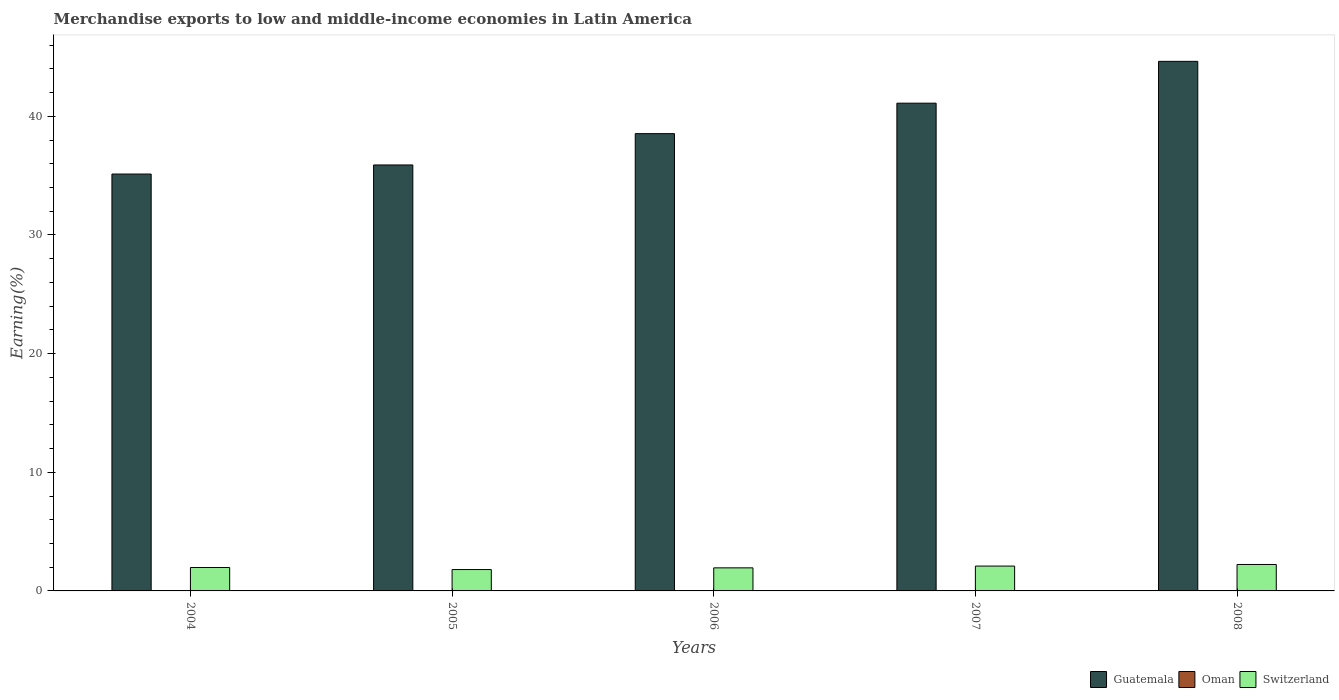How many bars are there on the 3rd tick from the right?
Give a very brief answer. 3. What is the label of the 4th group of bars from the left?
Your answer should be very brief. 2007. In how many cases, is the number of bars for a given year not equal to the number of legend labels?
Offer a terse response. 0. What is the percentage of amount earned from merchandise exports in Oman in 2008?
Provide a succinct answer. 0.01. Across all years, what is the maximum percentage of amount earned from merchandise exports in Switzerland?
Offer a terse response. 2.23. Across all years, what is the minimum percentage of amount earned from merchandise exports in Oman?
Ensure brevity in your answer.  0.01. In which year was the percentage of amount earned from merchandise exports in Switzerland maximum?
Your answer should be compact. 2008. What is the total percentage of amount earned from merchandise exports in Guatemala in the graph?
Give a very brief answer. 195.32. What is the difference between the percentage of amount earned from merchandise exports in Oman in 2005 and that in 2006?
Provide a succinct answer. -0.01. What is the difference between the percentage of amount earned from merchandise exports in Switzerland in 2007 and the percentage of amount earned from merchandise exports in Oman in 2006?
Provide a succinct answer. 2.07. What is the average percentage of amount earned from merchandise exports in Guatemala per year?
Keep it short and to the point. 39.06. In the year 2006, what is the difference between the percentage of amount earned from merchandise exports in Guatemala and percentage of amount earned from merchandise exports in Oman?
Make the answer very short. 38.52. In how many years, is the percentage of amount earned from merchandise exports in Switzerland greater than 24 %?
Your response must be concise. 0. What is the ratio of the percentage of amount earned from merchandise exports in Oman in 2004 to that in 2008?
Your answer should be compact. 0.6. What is the difference between the highest and the second highest percentage of amount earned from merchandise exports in Switzerland?
Provide a succinct answer. 0.13. What is the difference between the highest and the lowest percentage of amount earned from merchandise exports in Switzerland?
Provide a short and direct response. 0.43. In how many years, is the percentage of amount earned from merchandise exports in Switzerland greater than the average percentage of amount earned from merchandise exports in Switzerland taken over all years?
Your response must be concise. 2. What does the 2nd bar from the left in 2008 represents?
Make the answer very short. Oman. What does the 2nd bar from the right in 2007 represents?
Ensure brevity in your answer.  Oman. Are all the bars in the graph horizontal?
Keep it short and to the point. No. Are the values on the major ticks of Y-axis written in scientific E-notation?
Provide a short and direct response. No. Does the graph contain grids?
Your answer should be very brief. No. Where does the legend appear in the graph?
Your response must be concise. Bottom right. How are the legend labels stacked?
Provide a short and direct response. Horizontal. What is the title of the graph?
Your answer should be very brief. Merchandise exports to low and middle-income economies in Latin America. Does "Greenland" appear as one of the legend labels in the graph?
Provide a short and direct response. No. What is the label or title of the Y-axis?
Offer a terse response. Earning(%). What is the Earning(%) in Guatemala in 2004?
Keep it short and to the point. 35.14. What is the Earning(%) in Oman in 2004?
Your response must be concise. 0.01. What is the Earning(%) in Switzerland in 2004?
Ensure brevity in your answer.  1.97. What is the Earning(%) of Guatemala in 2005?
Provide a short and direct response. 35.9. What is the Earning(%) of Oman in 2005?
Offer a very short reply. 0.01. What is the Earning(%) in Switzerland in 2005?
Your response must be concise. 1.8. What is the Earning(%) of Guatemala in 2006?
Provide a succinct answer. 38.54. What is the Earning(%) of Oman in 2006?
Your answer should be compact. 0.02. What is the Earning(%) in Switzerland in 2006?
Provide a succinct answer. 1.94. What is the Earning(%) in Guatemala in 2007?
Keep it short and to the point. 41.11. What is the Earning(%) of Oman in 2007?
Offer a very short reply. 0.02. What is the Earning(%) of Switzerland in 2007?
Give a very brief answer. 2.09. What is the Earning(%) of Guatemala in 2008?
Keep it short and to the point. 44.63. What is the Earning(%) in Oman in 2008?
Make the answer very short. 0.01. What is the Earning(%) in Switzerland in 2008?
Ensure brevity in your answer.  2.23. Across all years, what is the maximum Earning(%) in Guatemala?
Your response must be concise. 44.63. Across all years, what is the maximum Earning(%) in Oman?
Your answer should be very brief. 0.02. Across all years, what is the maximum Earning(%) in Switzerland?
Make the answer very short. 2.23. Across all years, what is the minimum Earning(%) in Guatemala?
Offer a very short reply. 35.14. Across all years, what is the minimum Earning(%) of Oman?
Your answer should be very brief. 0.01. Across all years, what is the minimum Earning(%) of Switzerland?
Offer a very short reply. 1.8. What is the total Earning(%) of Guatemala in the graph?
Your response must be concise. 195.32. What is the total Earning(%) of Oman in the graph?
Keep it short and to the point. 0.06. What is the total Earning(%) in Switzerland in the graph?
Keep it short and to the point. 10.04. What is the difference between the Earning(%) in Guatemala in 2004 and that in 2005?
Your answer should be compact. -0.77. What is the difference between the Earning(%) in Oman in 2004 and that in 2005?
Keep it short and to the point. -0. What is the difference between the Earning(%) of Switzerland in 2004 and that in 2005?
Your answer should be very brief. 0.17. What is the difference between the Earning(%) of Guatemala in 2004 and that in 2006?
Provide a short and direct response. -3.41. What is the difference between the Earning(%) of Oman in 2004 and that in 2006?
Keep it short and to the point. -0.02. What is the difference between the Earning(%) in Switzerland in 2004 and that in 2006?
Give a very brief answer. 0.03. What is the difference between the Earning(%) of Guatemala in 2004 and that in 2007?
Your response must be concise. -5.97. What is the difference between the Earning(%) in Oman in 2004 and that in 2007?
Ensure brevity in your answer.  -0.01. What is the difference between the Earning(%) in Switzerland in 2004 and that in 2007?
Your response must be concise. -0.12. What is the difference between the Earning(%) in Guatemala in 2004 and that in 2008?
Provide a short and direct response. -9.5. What is the difference between the Earning(%) in Oman in 2004 and that in 2008?
Your response must be concise. -0. What is the difference between the Earning(%) in Switzerland in 2004 and that in 2008?
Your answer should be very brief. -0.26. What is the difference between the Earning(%) of Guatemala in 2005 and that in 2006?
Provide a succinct answer. -2.64. What is the difference between the Earning(%) of Oman in 2005 and that in 2006?
Provide a short and direct response. -0.01. What is the difference between the Earning(%) of Switzerland in 2005 and that in 2006?
Your answer should be very brief. -0.14. What is the difference between the Earning(%) in Guatemala in 2005 and that in 2007?
Keep it short and to the point. -5.21. What is the difference between the Earning(%) in Oman in 2005 and that in 2007?
Ensure brevity in your answer.  -0.01. What is the difference between the Earning(%) in Switzerland in 2005 and that in 2007?
Give a very brief answer. -0.29. What is the difference between the Earning(%) of Guatemala in 2005 and that in 2008?
Offer a very short reply. -8.73. What is the difference between the Earning(%) of Oman in 2005 and that in 2008?
Give a very brief answer. -0. What is the difference between the Earning(%) of Switzerland in 2005 and that in 2008?
Your answer should be very brief. -0.43. What is the difference between the Earning(%) of Guatemala in 2006 and that in 2007?
Your response must be concise. -2.57. What is the difference between the Earning(%) in Oman in 2006 and that in 2007?
Provide a succinct answer. 0. What is the difference between the Earning(%) in Switzerland in 2006 and that in 2007?
Your answer should be very brief. -0.15. What is the difference between the Earning(%) of Guatemala in 2006 and that in 2008?
Your response must be concise. -6.09. What is the difference between the Earning(%) of Oman in 2006 and that in 2008?
Ensure brevity in your answer.  0.01. What is the difference between the Earning(%) in Switzerland in 2006 and that in 2008?
Your response must be concise. -0.28. What is the difference between the Earning(%) of Guatemala in 2007 and that in 2008?
Offer a very short reply. -3.53. What is the difference between the Earning(%) in Oman in 2007 and that in 2008?
Provide a short and direct response. 0.01. What is the difference between the Earning(%) in Switzerland in 2007 and that in 2008?
Offer a terse response. -0.13. What is the difference between the Earning(%) in Guatemala in 2004 and the Earning(%) in Oman in 2005?
Keep it short and to the point. 35.13. What is the difference between the Earning(%) in Guatemala in 2004 and the Earning(%) in Switzerland in 2005?
Ensure brevity in your answer.  33.33. What is the difference between the Earning(%) of Oman in 2004 and the Earning(%) of Switzerland in 2005?
Keep it short and to the point. -1.8. What is the difference between the Earning(%) in Guatemala in 2004 and the Earning(%) in Oman in 2006?
Your response must be concise. 35.11. What is the difference between the Earning(%) in Guatemala in 2004 and the Earning(%) in Switzerland in 2006?
Give a very brief answer. 33.19. What is the difference between the Earning(%) of Oman in 2004 and the Earning(%) of Switzerland in 2006?
Make the answer very short. -1.94. What is the difference between the Earning(%) in Guatemala in 2004 and the Earning(%) in Oman in 2007?
Provide a succinct answer. 35.12. What is the difference between the Earning(%) of Guatemala in 2004 and the Earning(%) of Switzerland in 2007?
Your response must be concise. 33.04. What is the difference between the Earning(%) in Oman in 2004 and the Earning(%) in Switzerland in 2007?
Your response must be concise. -2.09. What is the difference between the Earning(%) in Guatemala in 2004 and the Earning(%) in Oman in 2008?
Your answer should be very brief. 35.13. What is the difference between the Earning(%) in Guatemala in 2004 and the Earning(%) in Switzerland in 2008?
Offer a very short reply. 32.91. What is the difference between the Earning(%) in Oman in 2004 and the Earning(%) in Switzerland in 2008?
Ensure brevity in your answer.  -2.22. What is the difference between the Earning(%) of Guatemala in 2005 and the Earning(%) of Oman in 2006?
Make the answer very short. 35.88. What is the difference between the Earning(%) of Guatemala in 2005 and the Earning(%) of Switzerland in 2006?
Your response must be concise. 33.96. What is the difference between the Earning(%) of Oman in 2005 and the Earning(%) of Switzerland in 2006?
Provide a succinct answer. -1.94. What is the difference between the Earning(%) in Guatemala in 2005 and the Earning(%) in Oman in 2007?
Provide a succinct answer. 35.88. What is the difference between the Earning(%) of Guatemala in 2005 and the Earning(%) of Switzerland in 2007?
Ensure brevity in your answer.  33.81. What is the difference between the Earning(%) in Oman in 2005 and the Earning(%) in Switzerland in 2007?
Your answer should be very brief. -2.09. What is the difference between the Earning(%) in Guatemala in 2005 and the Earning(%) in Oman in 2008?
Provide a short and direct response. 35.89. What is the difference between the Earning(%) in Guatemala in 2005 and the Earning(%) in Switzerland in 2008?
Offer a very short reply. 33.67. What is the difference between the Earning(%) of Oman in 2005 and the Earning(%) of Switzerland in 2008?
Keep it short and to the point. -2.22. What is the difference between the Earning(%) in Guatemala in 2006 and the Earning(%) in Oman in 2007?
Offer a terse response. 38.52. What is the difference between the Earning(%) in Guatemala in 2006 and the Earning(%) in Switzerland in 2007?
Make the answer very short. 36.45. What is the difference between the Earning(%) of Oman in 2006 and the Earning(%) of Switzerland in 2007?
Your response must be concise. -2.07. What is the difference between the Earning(%) of Guatemala in 2006 and the Earning(%) of Oman in 2008?
Make the answer very short. 38.53. What is the difference between the Earning(%) in Guatemala in 2006 and the Earning(%) in Switzerland in 2008?
Keep it short and to the point. 36.31. What is the difference between the Earning(%) of Oman in 2006 and the Earning(%) of Switzerland in 2008?
Offer a very short reply. -2.21. What is the difference between the Earning(%) of Guatemala in 2007 and the Earning(%) of Oman in 2008?
Your response must be concise. 41.1. What is the difference between the Earning(%) in Guatemala in 2007 and the Earning(%) in Switzerland in 2008?
Provide a succinct answer. 38.88. What is the difference between the Earning(%) in Oman in 2007 and the Earning(%) in Switzerland in 2008?
Keep it short and to the point. -2.21. What is the average Earning(%) in Guatemala per year?
Keep it short and to the point. 39.06. What is the average Earning(%) of Oman per year?
Keep it short and to the point. 0.01. What is the average Earning(%) in Switzerland per year?
Ensure brevity in your answer.  2.01. In the year 2004, what is the difference between the Earning(%) in Guatemala and Earning(%) in Oman?
Offer a terse response. 35.13. In the year 2004, what is the difference between the Earning(%) in Guatemala and Earning(%) in Switzerland?
Offer a very short reply. 33.16. In the year 2004, what is the difference between the Earning(%) in Oman and Earning(%) in Switzerland?
Provide a succinct answer. -1.97. In the year 2005, what is the difference between the Earning(%) of Guatemala and Earning(%) of Oman?
Provide a short and direct response. 35.89. In the year 2005, what is the difference between the Earning(%) in Guatemala and Earning(%) in Switzerland?
Ensure brevity in your answer.  34.1. In the year 2005, what is the difference between the Earning(%) of Oman and Earning(%) of Switzerland?
Your answer should be compact. -1.79. In the year 2006, what is the difference between the Earning(%) in Guatemala and Earning(%) in Oman?
Keep it short and to the point. 38.52. In the year 2006, what is the difference between the Earning(%) in Guatemala and Earning(%) in Switzerland?
Keep it short and to the point. 36.6. In the year 2006, what is the difference between the Earning(%) of Oman and Earning(%) of Switzerland?
Your answer should be compact. -1.92. In the year 2007, what is the difference between the Earning(%) of Guatemala and Earning(%) of Oman?
Your answer should be compact. 41.09. In the year 2007, what is the difference between the Earning(%) of Guatemala and Earning(%) of Switzerland?
Keep it short and to the point. 39.01. In the year 2007, what is the difference between the Earning(%) of Oman and Earning(%) of Switzerland?
Make the answer very short. -2.07. In the year 2008, what is the difference between the Earning(%) of Guatemala and Earning(%) of Oman?
Offer a very short reply. 44.62. In the year 2008, what is the difference between the Earning(%) of Guatemala and Earning(%) of Switzerland?
Offer a terse response. 42.4. In the year 2008, what is the difference between the Earning(%) of Oman and Earning(%) of Switzerland?
Your answer should be very brief. -2.22. What is the ratio of the Earning(%) of Guatemala in 2004 to that in 2005?
Give a very brief answer. 0.98. What is the ratio of the Earning(%) of Oman in 2004 to that in 2005?
Your answer should be very brief. 0.71. What is the ratio of the Earning(%) of Switzerland in 2004 to that in 2005?
Keep it short and to the point. 1.1. What is the ratio of the Earning(%) of Guatemala in 2004 to that in 2006?
Offer a very short reply. 0.91. What is the ratio of the Earning(%) of Oman in 2004 to that in 2006?
Ensure brevity in your answer.  0.25. What is the ratio of the Earning(%) in Switzerland in 2004 to that in 2006?
Your answer should be compact. 1.01. What is the ratio of the Earning(%) of Guatemala in 2004 to that in 2007?
Your answer should be very brief. 0.85. What is the ratio of the Earning(%) of Oman in 2004 to that in 2007?
Make the answer very short. 0.27. What is the ratio of the Earning(%) in Switzerland in 2004 to that in 2007?
Offer a terse response. 0.94. What is the ratio of the Earning(%) in Guatemala in 2004 to that in 2008?
Your response must be concise. 0.79. What is the ratio of the Earning(%) of Oman in 2004 to that in 2008?
Your answer should be very brief. 0.6. What is the ratio of the Earning(%) in Switzerland in 2004 to that in 2008?
Ensure brevity in your answer.  0.89. What is the ratio of the Earning(%) of Guatemala in 2005 to that in 2006?
Your answer should be compact. 0.93. What is the ratio of the Earning(%) of Oman in 2005 to that in 2006?
Offer a very short reply. 0.35. What is the ratio of the Earning(%) in Switzerland in 2005 to that in 2006?
Offer a terse response. 0.93. What is the ratio of the Earning(%) of Guatemala in 2005 to that in 2007?
Your answer should be compact. 0.87. What is the ratio of the Earning(%) of Oman in 2005 to that in 2007?
Your answer should be very brief. 0.38. What is the ratio of the Earning(%) of Switzerland in 2005 to that in 2007?
Your answer should be compact. 0.86. What is the ratio of the Earning(%) in Guatemala in 2005 to that in 2008?
Your answer should be compact. 0.8. What is the ratio of the Earning(%) in Oman in 2005 to that in 2008?
Offer a terse response. 0.85. What is the ratio of the Earning(%) in Switzerland in 2005 to that in 2008?
Provide a short and direct response. 0.81. What is the ratio of the Earning(%) in Guatemala in 2006 to that in 2007?
Provide a succinct answer. 0.94. What is the ratio of the Earning(%) of Oman in 2006 to that in 2007?
Your response must be concise. 1.08. What is the ratio of the Earning(%) of Switzerland in 2006 to that in 2007?
Offer a very short reply. 0.93. What is the ratio of the Earning(%) of Guatemala in 2006 to that in 2008?
Offer a very short reply. 0.86. What is the ratio of the Earning(%) in Oman in 2006 to that in 2008?
Provide a short and direct response. 2.41. What is the ratio of the Earning(%) of Switzerland in 2006 to that in 2008?
Ensure brevity in your answer.  0.87. What is the ratio of the Earning(%) in Guatemala in 2007 to that in 2008?
Make the answer very short. 0.92. What is the ratio of the Earning(%) in Oman in 2007 to that in 2008?
Offer a very short reply. 2.23. What is the ratio of the Earning(%) of Switzerland in 2007 to that in 2008?
Make the answer very short. 0.94. What is the difference between the highest and the second highest Earning(%) of Guatemala?
Your answer should be compact. 3.53. What is the difference between the highest and the second highest Earning(%) in Oman?
Offer a terse response. 0. What is the difference between the highest and the second highest Earning(%) in Switzerland?
Offer a very short reply. 0.13. What is the difference between the highest and the lowest Earning(%) of Guatemala?
Ensure brevity in your answer.  9.5. What is the difference between the highest and the lowest Earning(%) of Oman?
Your response must be concise. 0.02. What is the difference between the highest and the lowest Earning(%) of Switzerland?
Provide a succinct answer. 0.43. 